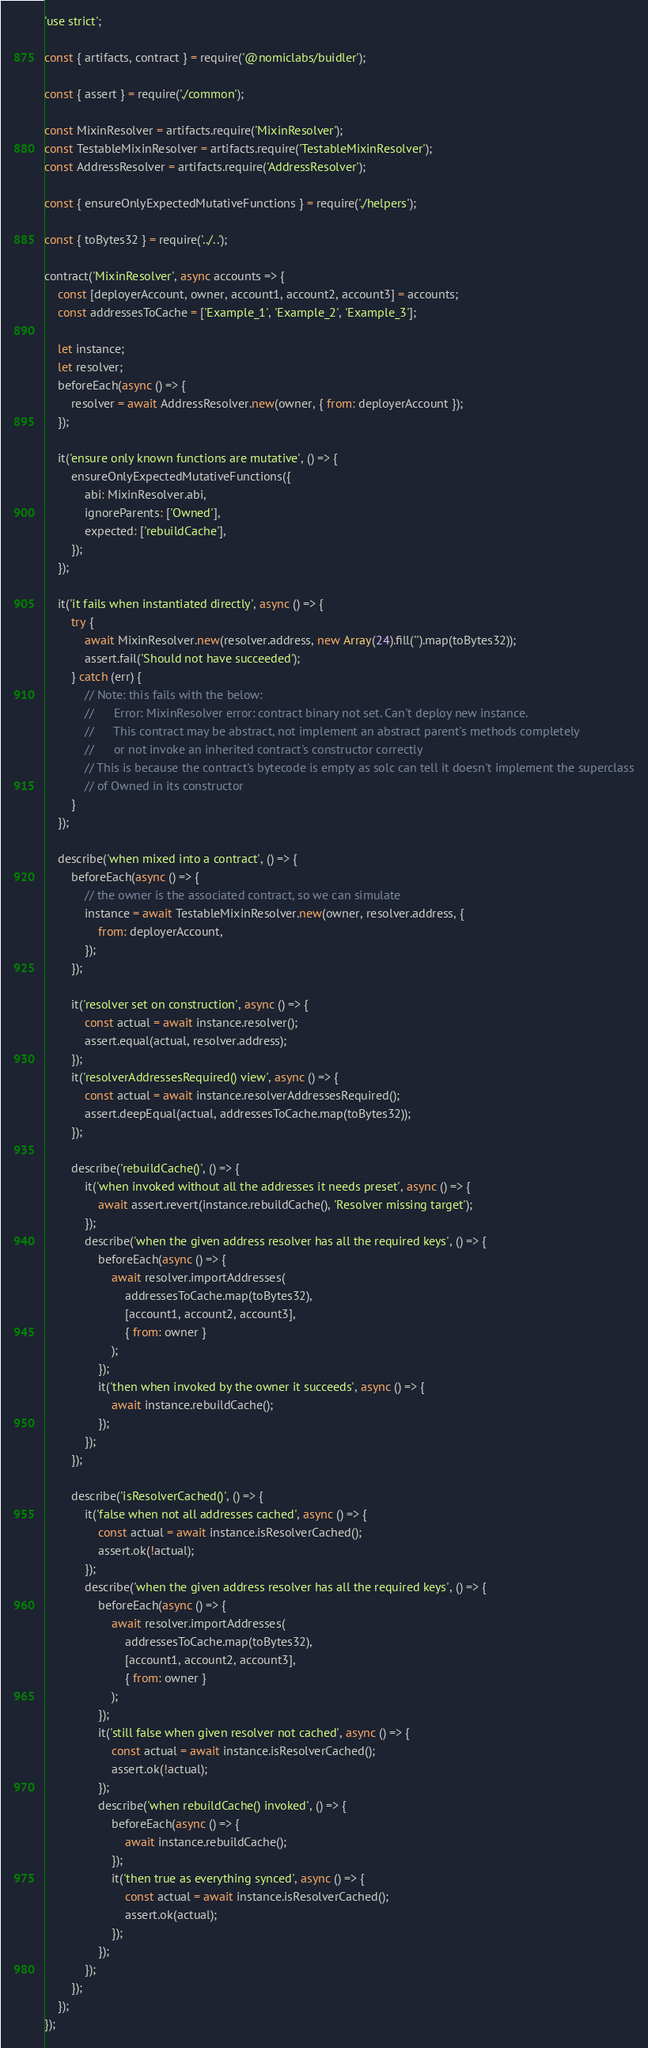<code> <loc_0><loc_0><loc_500><loc_500><_JavaScript_>'use strict';

const { artifacts, contract } = require('@nomiclabs/buidler');

const { assert } = require('./common');

const MixinResolver = artifacts.require('MixinResolver');
const TestableMixinResolver = artifacts.require('TestableMixinResolver');
const AddressResolver = artifacts.require('AddressResolver');

const { ensureOnlyExpectedMutativeFunctions } = require('./helpers');

const { toBytes32 } = require('../..');

contract('MixinResolver', async accounts => {
	const [deployerAccount, owner, account1, account2, account3] = accounts;
	const addressesToCache = ['Example_1', 'Example_2', 'Example_3'];

	let instance;
	let resolver;
	beforeEach(async () => {
		resolver = await AddressResolver.new(owner, { from: deployerAccount });
	});

	it('ensure only known functions are mutative', () => {
		ensureOnlyExpectedMutativeFunctions({
			abi: MixinResolver.abi,
			ignoreParents: ['Owned'],
			expected: ['rebuildCache'],
		});
	});

	it('it fails when instantiated directly', async () => {
		try {
			await MixinResolver.new(resolver.address, new Array(24).fill('').map(toBytes32));
			assert.fail('Should not have succeeded');
		} catch (err) {
			// Note: this fails with the below:
			// 		Error: MixinResolver error: contract binary not set. Can't deploy new instance.
			// 		This contract may be abstract, not implement an abstract parent's methods completely
			// 		or not invoke an inherited contract's constructor correctly
			// This is because the contract's bytecode is empty as solc can tell it doesn't implement the superclass
			// of Owned in its constructor
		}
	});

	describe('when mixed into a contract', () => {
		beforeEach(async () => {
			// the owner is the associated contract, so we can simulate
			instance = await TestableMixinResolver.new(owner, resolver.address, {
				from: deployerAccount,
			});
		});

		it('resolver set on construction', async () => {
			const actual = await instance.resolver();
			assert.equal(actual, resolver.address);
		});
		it('resolverAddressesRequired() view', async () => {
			const actual = await instance.resolverAddressesRequired();
			assert.deepEqual(actual, addressesToCache.map(toBytes32));
		});

		describe('rebuildCache()', () => {
			it('when invoked without all the addresses it needs preset', async () => {
				await assert.revert(instance.rebuildCache(), 'Resolver missing target');
			});
			describe('when the given address resolver has all the required keys', () => {
				beforeEach(async () => {
					await resolver.importAddresses(
						addressesToCache.map(toBytes32),
						[account1, account2, account3],
						{ from: owner }
					);
				});
				it('then when invoked by the owner it succeeds', async () => {
					await instance.rebuildCache();
				});
			});
		});

		describe('isResolverCached()', () => {
			it('false when not all addresses cached', async () => {
				const actual = await instance.isResolverCached();
				assert.ok(!actual);
			});
			describe('when the given address resolver has all the required keys', () => {
				beforeEach(async () => {
					await resolver.importAddresses(
						addressesToCache.map(toBytes32),
						[account1, account2, account3],
						{ from: owner }
					);
				});
				it('still false when given resolver not cached', async () => {
					const actual = await instance.isResolverCached();
					assert.ok(!actual);
				});
				describe('when rebuildCache() invoked', () => {
					beforeEach(async () => {
						await instance.rebuildCache();
					});
					it('then true as everything synced', async () => {
						const actual = await instance.isResolverCached();
						assert.ok(actual);
					});
				});
			});
		});
	});
});
</code> 